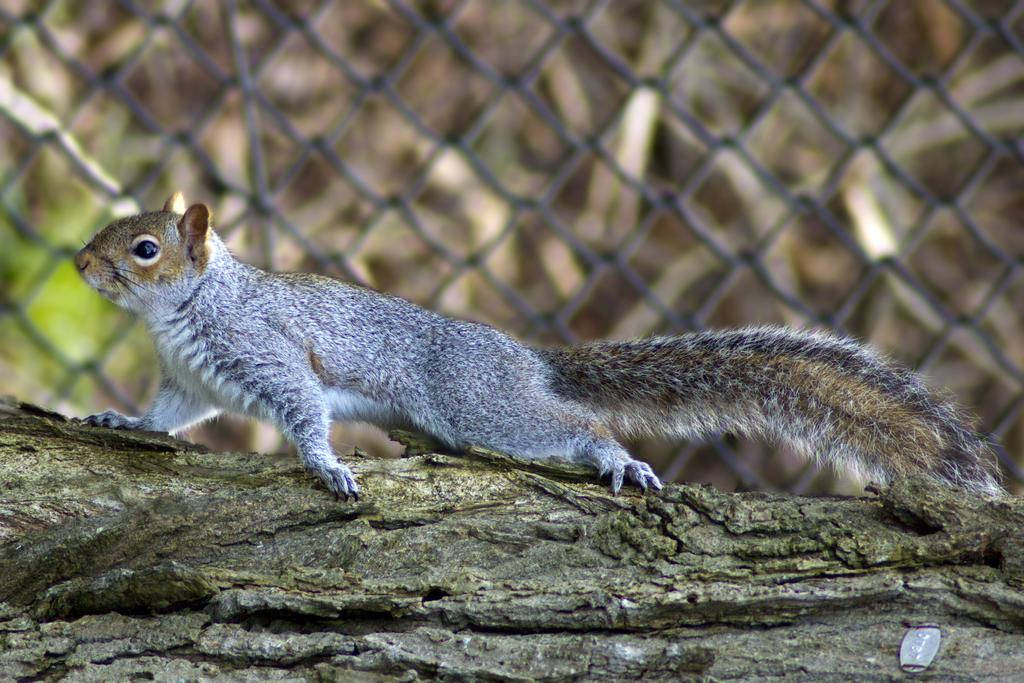What animal is in the middle of the image? There is a squirrel in the middle of the image. What can be seen in the background of the image? There is an iron net visible in the background of the image. How many people are in the crowd surrounding the squirrel in the image? There is no crowd present in the image; it only features a squirrel and an iron net in the background. 